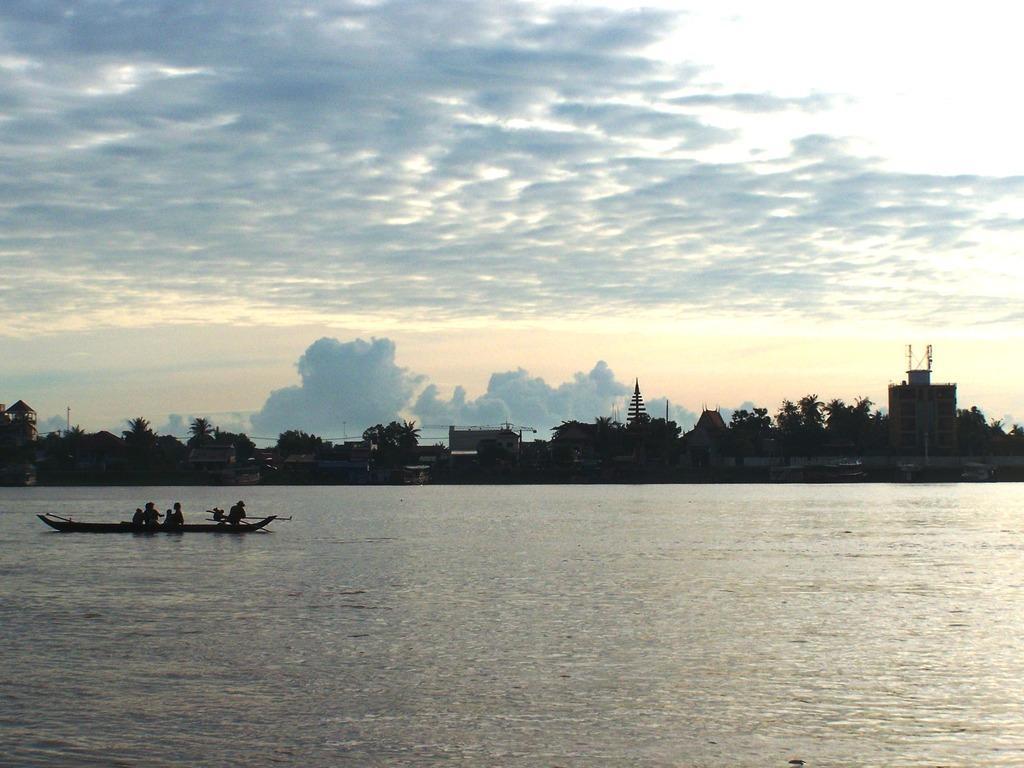In one or two sentences, can you explain what this image depicts? In this image there is water and we can see a boat on the water. There are people sitting on the boat. In the background there are trees, buildings and sky. 